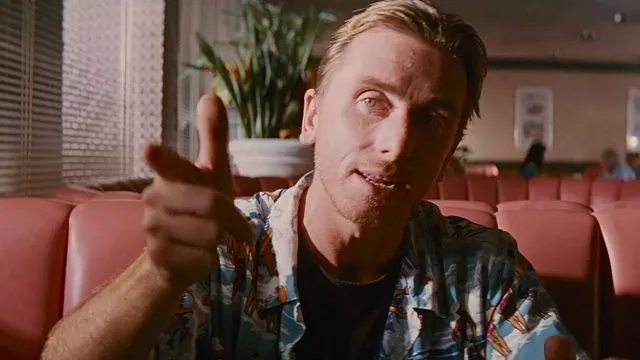Can you describe the main features of this image for me?
 In this image, we see Tim Roth, the acclaimed actor, in his iconic role as Mr. Orange from the movie Reservoir Dogs. He is seated comfortably in a booth within a diner, his right hand casually pointing towards the camera. His left hand is relaxed on the table. He is wearing a vibrant blue Hawaiian shirt that stands out in the scene. His hair is neatly slicked back, adding to his character's distinctive style. A slight smile plays on his face, hinting at the charisma of Mr. Orange. The background of the image is softly blurred, but we can discern the presence of other booths and a plant in the corner, adding depth to the setting. 